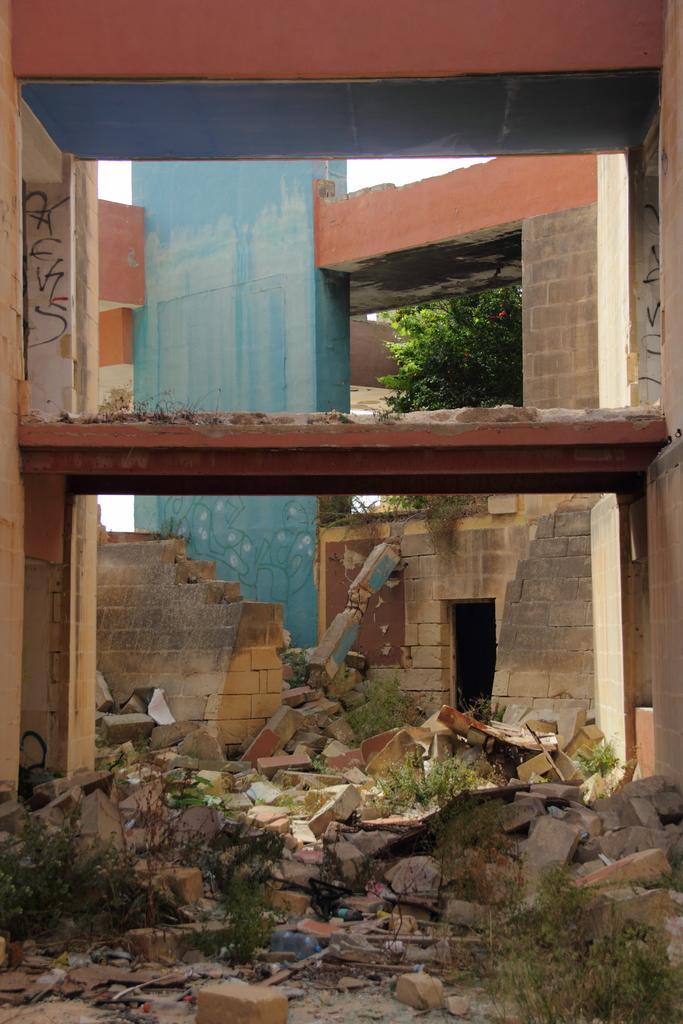Can you describe this image briefly? At the bottom of the image I can see some bricks and plants on the ground. In the background there is a building, stairs and a tree. 